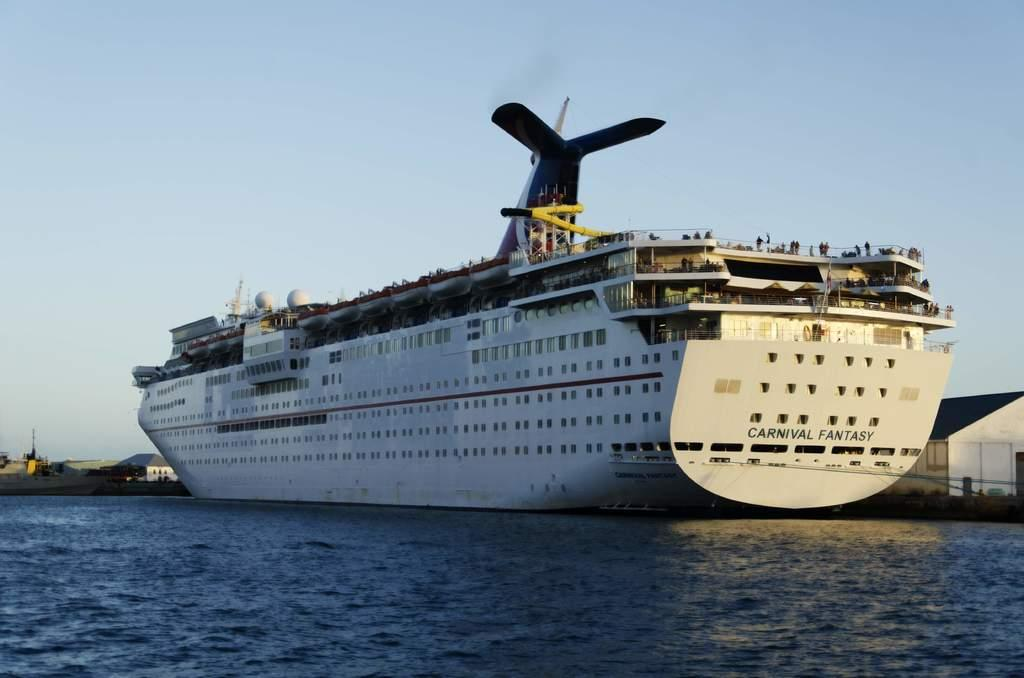<image>
Describe the image concisely. A large Carnival Fantasy cruise ship on open water. 